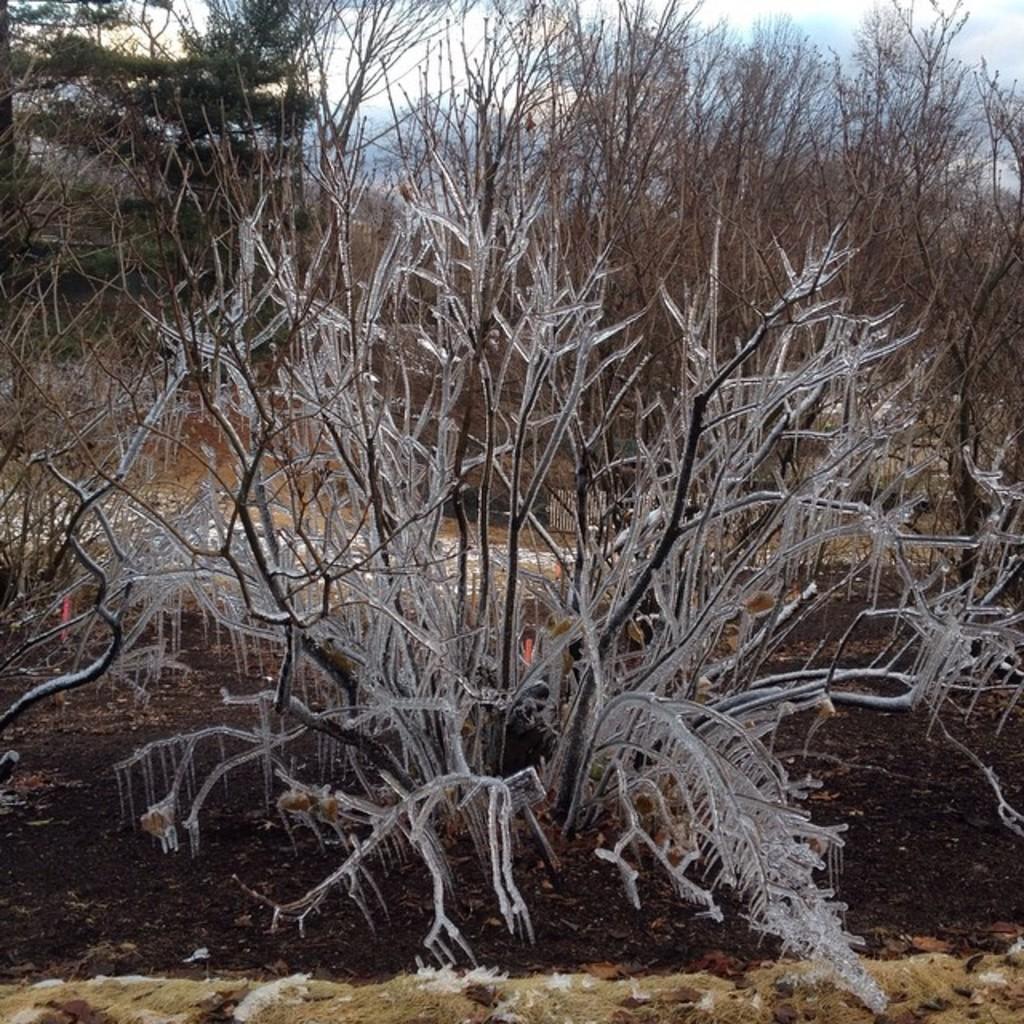In one or two sentences, can you explain what this image depicts? In the picture I can see a dried plant which has ice on it and there are few dried plants in the background. 